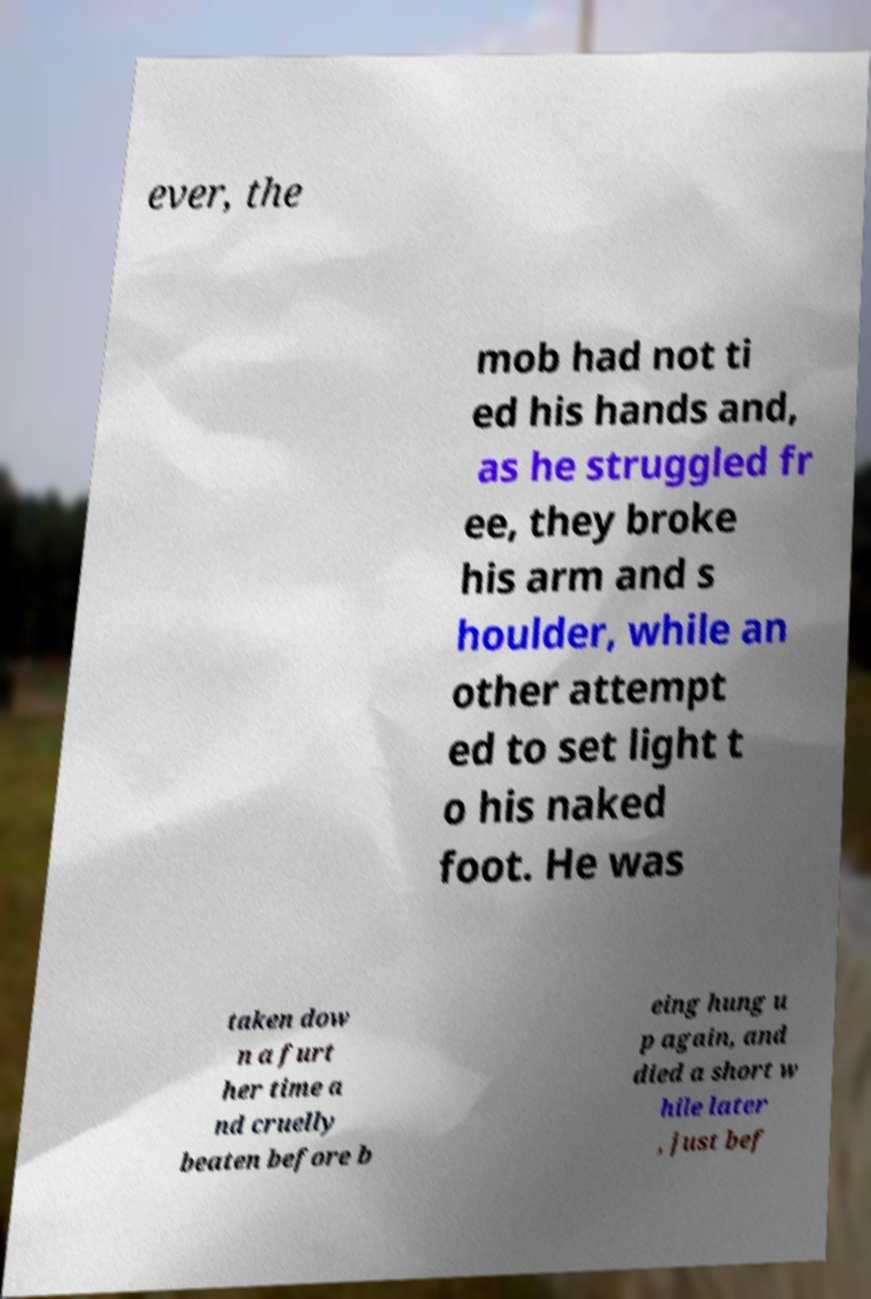What messages or text are displayed in this image? I need them in a readable, typed format. ever, the mob had not ti ed his hands and, as he struggled fr ee, they broke his arm and s houlder, while an other attempt ed to set light t o his naked foot. He was taken dow n a furt her time a nd cruelly beaten before b eing hung u p again, and died a short w hile later , just bef 